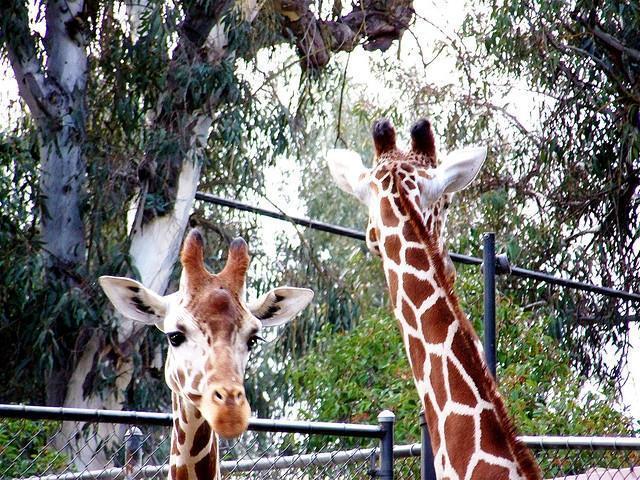How many giraffes are there?
Give a very brief answer. 2. 